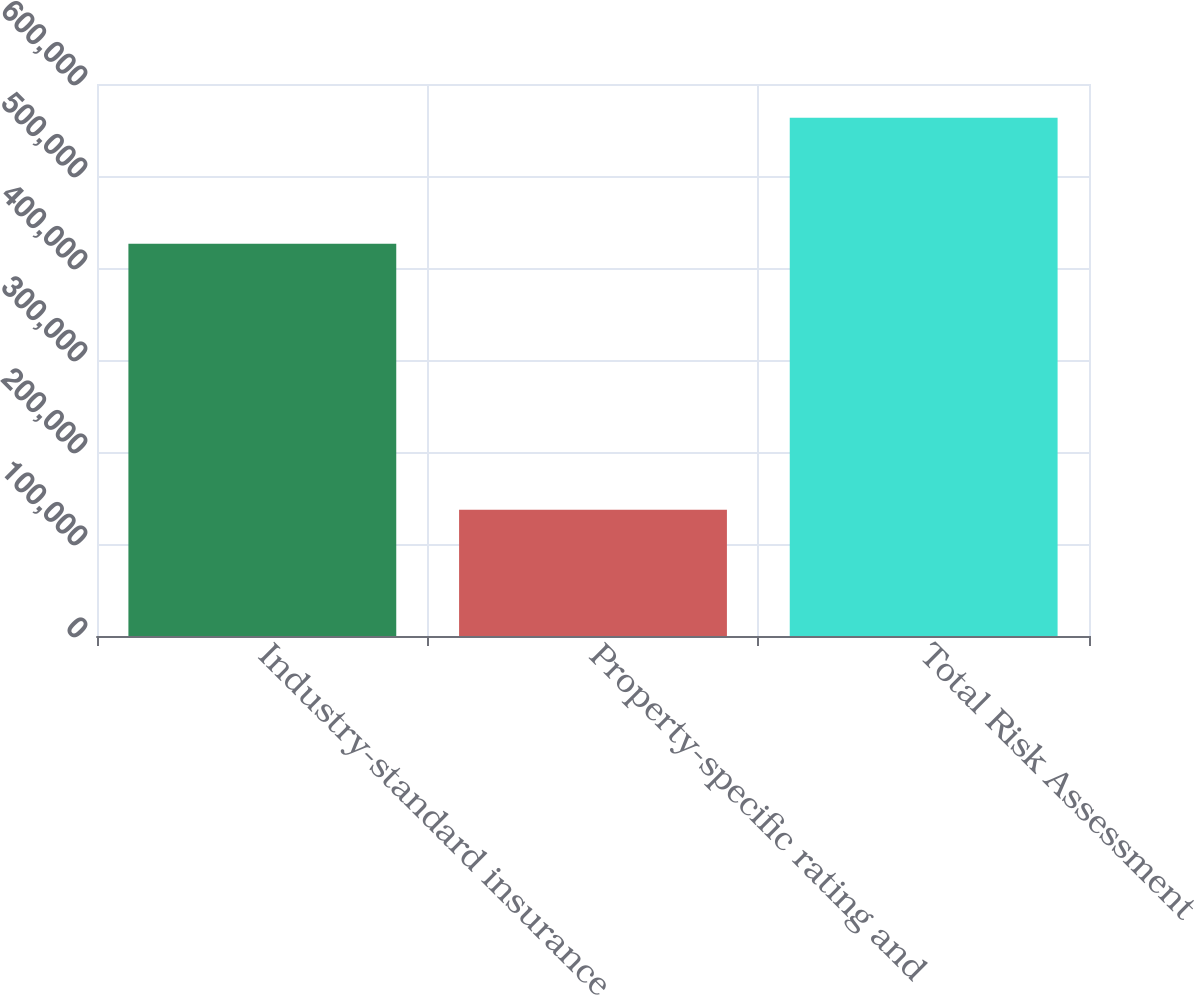Convert chart to OTSL. <chart><loc_0><loc_0><loc_500><loc_500><bar_chart><fcel>Industry-standard insurance<fcel>Property-specific rating and<fcel>Total Risk Assessment<nl><fcel>426228<fcel>137133<fcel>563361<nl></chart> 